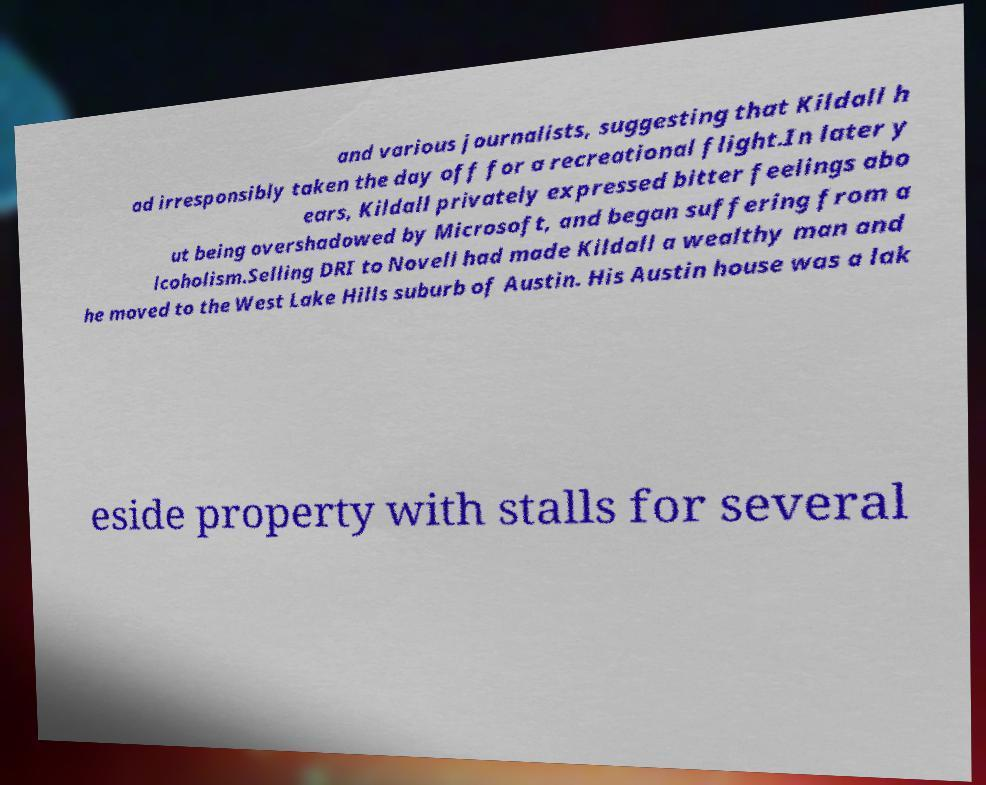There's text embedded in this image that I need extracted. Can you transcribe it verbatim? and various journalists, suggesting that Kildall h ad irresponsibly taken the day off for a recreational flight.In later y ears, Kildall privately expressed bitter feelings abo ut being overshadowed by Microsoft, and began suffering from a lcoholism.Selling DRI to Novell had made Kildall a wealthy man and he moved to the West Lake Hills suburb of Austin. His Austin house was a lak eside property with stalls for several 